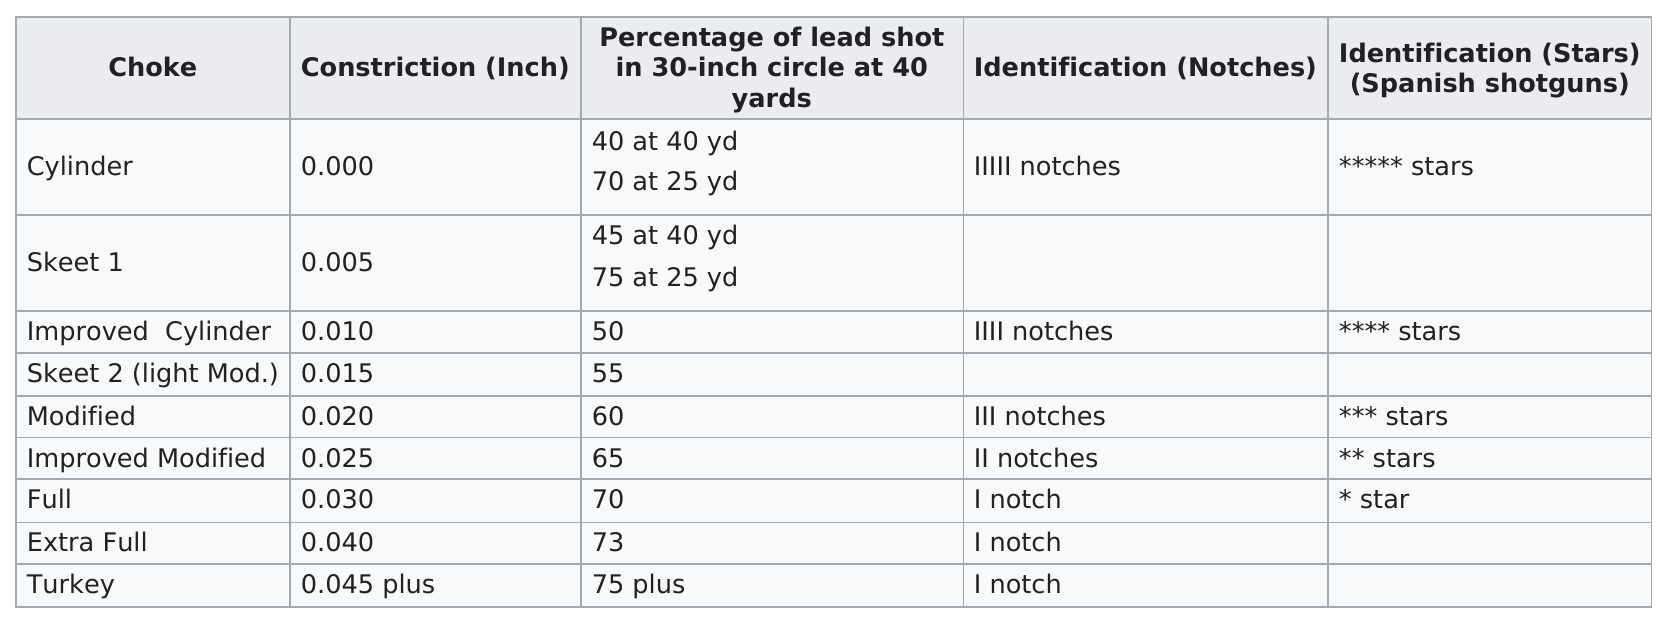Specify some key components in this picture. There are two different chokes that start with the letter "s". The choke with at least 0.005 inches of constriction is known as Skeet 1. The cylinder choke has the least constriction among the three types of chokes, offering a smooth and consistent release of targets. The difference in lead shot percentage at 25 yards between cylinder and skeet 1 barrels is 5%. Out of the various barrel types tested, four were found to contain over 60% lead shot within a 30 inch circle at a distance of 40 yards. 